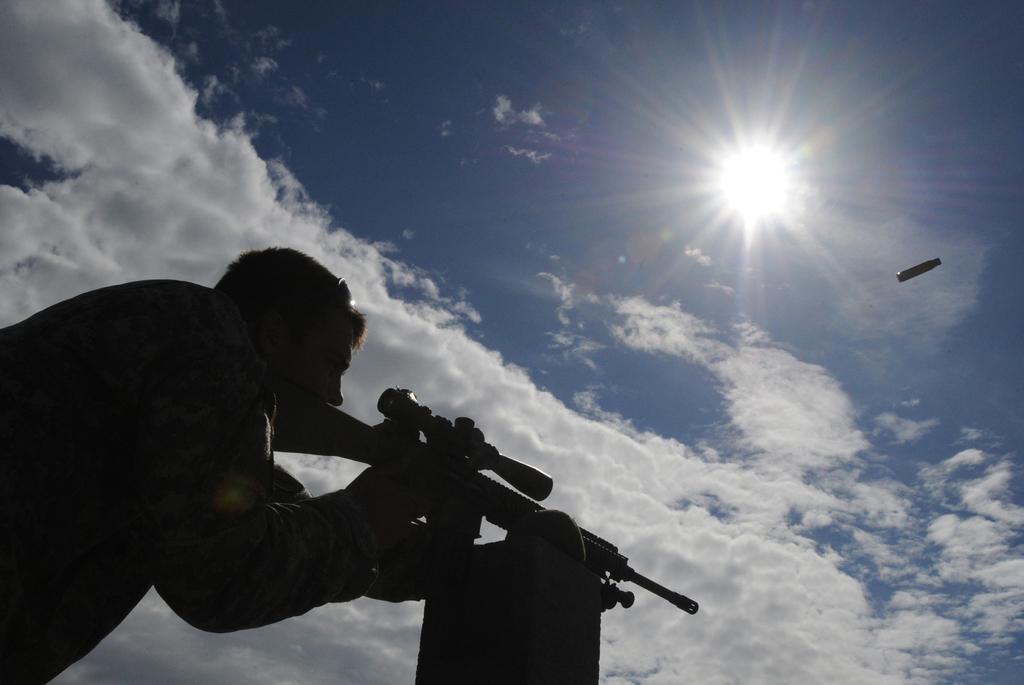How would you summarize this image in a sentence or two? On the left side, the man in the uniform is holding a rifle in his hands. In front of him, we see something which looks like a cement pillar. On the right side, we see an object and it looks like a bullet. In the background, we see the sun, the clouds and the sky. 